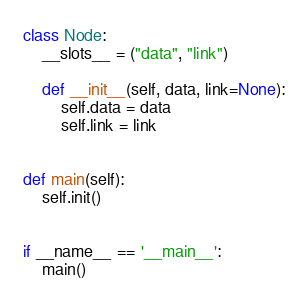<code> <loc_0><loc_0><loc_500><loc_500><_Python_>class Node:
    __slots__ = ("data", "link")

    def __init__(self, data, link=None):
        self.data = data
        self.link = link


def main(self):
    self.init()


if __name__ == '__main__':
    main()
</code> 